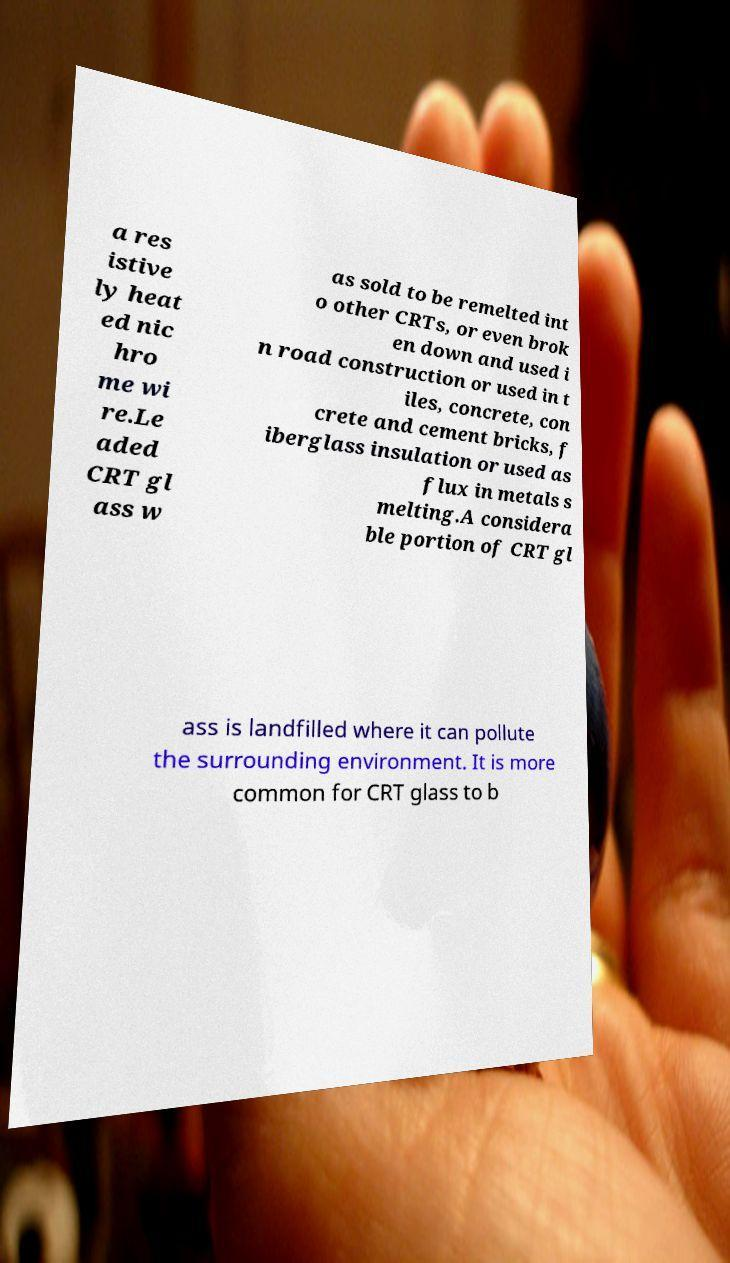Please identify and transcribe the text found in this image. a res istive ly heat ed nic hro me wi re.Le aded CRT gl ass w as sold to be remelted int o other CRTs, or even brok en down and used i n road construction or used in t iles, concrete, con crete and cement bricks, f iberglass insulation or used as flux in metals s melting.A considera ble portion of CRT gl ass is landfilled where it can pollute the surrounding environment. It is more common for CRT glass to b 